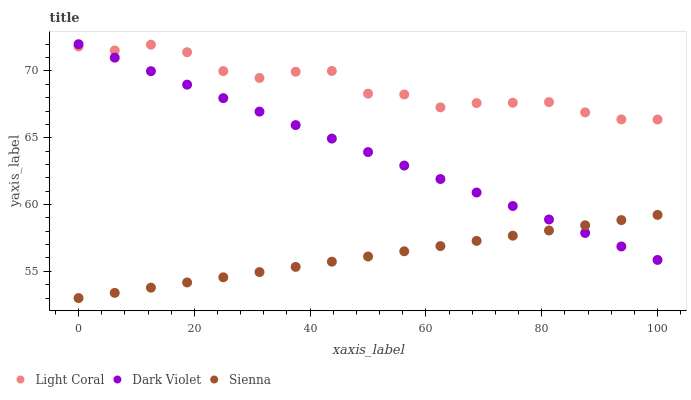Does Sienna have the minimum area under the curve?
Answer yes or no. Yes. Does Light Coral have the maximum area under the curve?
Answer yes or no. Yes. Does Dark Violet have the minimum area under the curve?
Answer yes or no. No. Does Dark Violet have the maximum area under the curve?
Answer yes or no. No. Is Sienna the smoothest?
Answer yes or no. Yes. Is Light Coral the roughest?
Answer yes or no. Yes. Is Dark Violet the smoothest?
Answer yes or no. No. Is Dark Violet the roughest?
Answer yes or no. No. Does Sienna have the lowest value?
Answer yes or no. Yes. Does Dark Violet have the lowest value?
Answer yes or no. No. Does Dark Violet have the highest value?
Answer yes or no. Yes. Does Sienna have the highest value?
Answer yes or no. No. Is Sienna less than Light Coral?
Answer yes or no. Yes. Is Light Coral greater than Sienna?
Answer yes or no. Yes. Does Dark Violet intersect Sienna?
Answer yes or no. Yes. Is Dark Violet less than Sienna?
Answer yes or no. No. Is Dark Violet greater than Sienna?
Answer yes or no. No. Does Sienna intersect Light Coral?
Answer yes or no. No. 